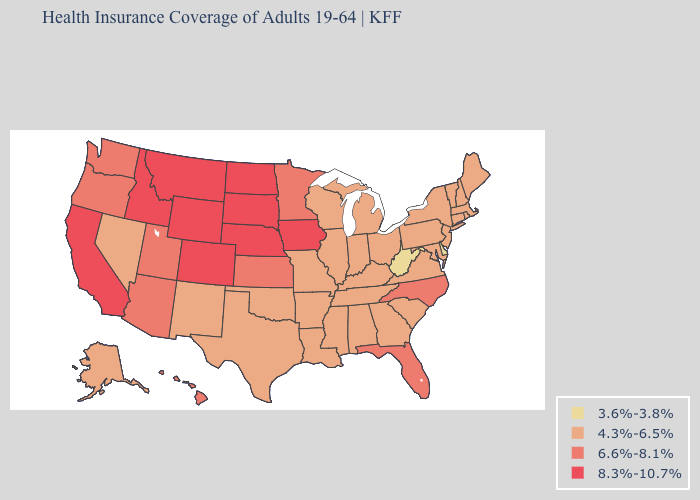What is the highest value in the USA?
Answer briefly. 8.3%-10.7%. Which states have the lowest value in the USA?
Write a very short answer. Delaware, West Virginia. What is the lowest value in the MidWest?
Answer briefly. 4.3%-6.5%. What is the value of Michigan?
Keep it brief. 4.3%-6.5%. Name the states that have a value in the range 4.3%-6.5%?
Concise answer only. Alabama, Alaska, Arkansas, Connecticut, Georgia, Illinois, Indiana, Kentucky, Louisiana, Maine, Maryland, Massachusetts, Michigan, Mississippi, Missouri, Nevada, New Hampshire, New Jersey, New Mexico, New York, Ohio, Oklahoma, Pennsylvania, Rhode Island, South Carolina, Tennessee, Texas, Vermont, Virginia, Wisconsin. What is the highest value in the West ?
Keep it brief. 8.3%-10.7%. Name the states that have a value in the range 3.6%-3.8%?
Be succinct. Delaware, West Virginia. What is the value of Minnesota?
Answer briefly. 6.6%-8.1%. Does West Virginia have a lower value than Delaware?
Keep it brief. No. What is the lowest value in the Northeast?
Keep it brief. 4.3%-6.5%. Name the states that have a value in the range 8.3%-10.7%?
Be succinct. California, Colorado, Idaho, Iowa, Montana, Nebraska, North Dakota, South Dakota, Wyoming. What is the highest value in the West ?
Give a very brief answer. 8.3%-10.7%. What is the value of Maine?
Answer briefly. 4.3%-6.5%. 